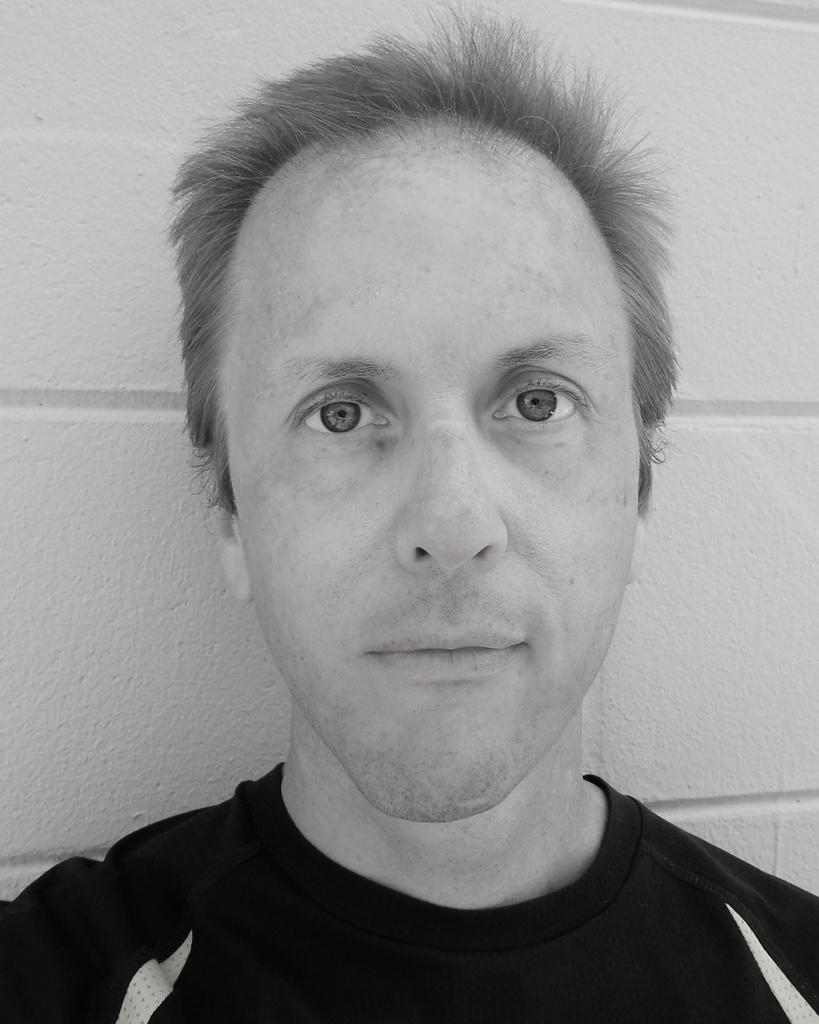Who is present in the image? There is a man in the image. What is the color scheme of the image? The image is black and white. What type of fuel is being used by the airplane in the image? There is no airplane present in the image, so it is not possible to determine what type of fuel is being used. 